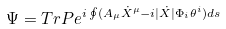<formula> <loc_0><loc_0><loc_500><loc_500>\Psi = T r P e ^ { i \oint ( A _ { \mu } \dot { X } ^ { \mu } - i | \dot { X } | \Phi _ { i } \theta ^ { i } ) d s }</formula> 